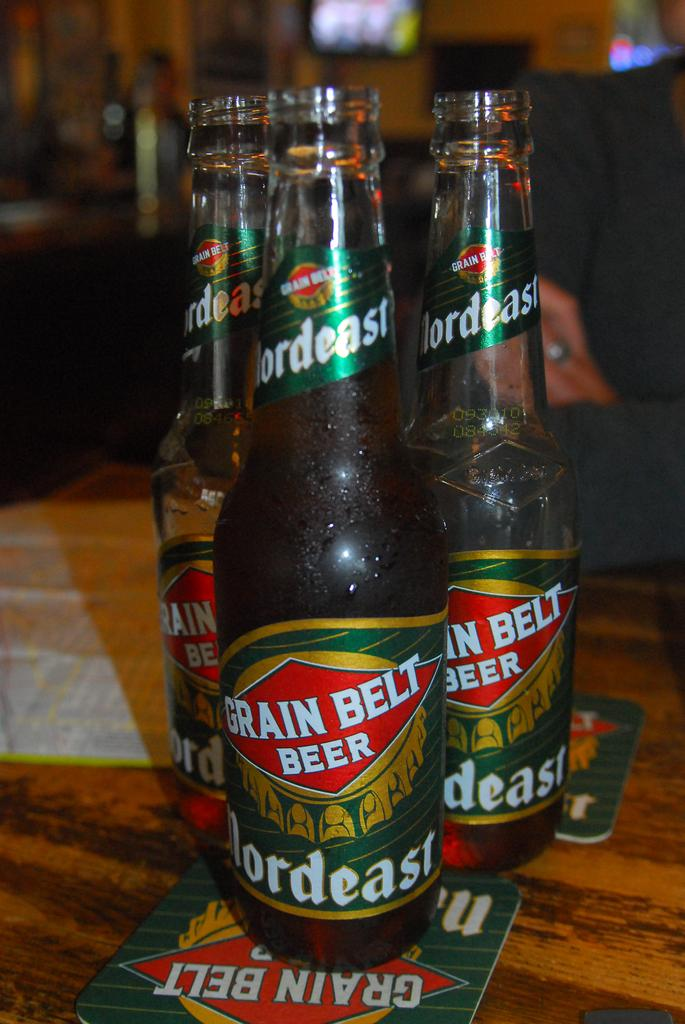<image>
Summarize the visual content of the image. A few bottles of Grain Belt Beer sit on coasters that also say Grain Belt on them. 